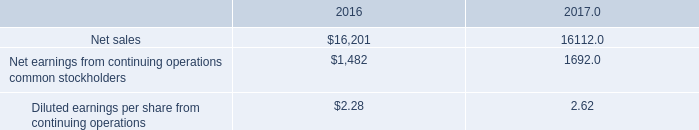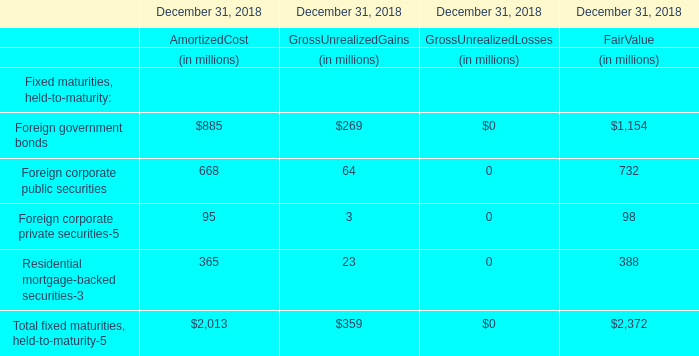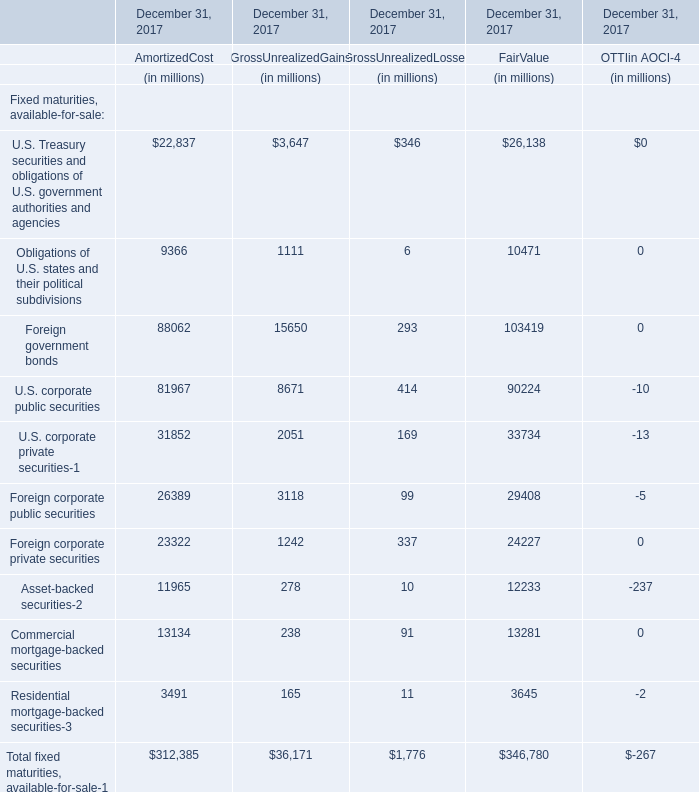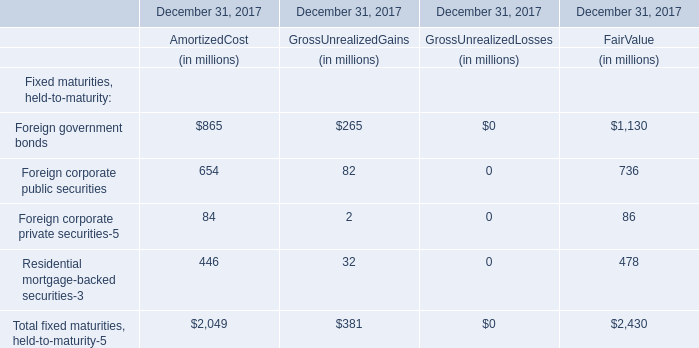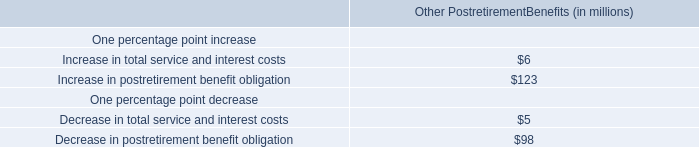What's the 40 % of total fixed maturities, held-to-maturity-5 for fair value in 2018? (in million) 
Computations: (2372 * 0.4)
Answer: 948.8. 